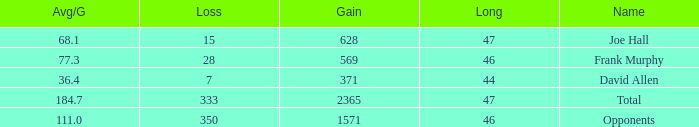How much Loss has a Gain smaller than 1571, and a Long smaller than 47, and an Avg/G of 36.4? 1.0. Can you give me this table as a dict? {'header': ['Avg/G', 'Loss', 'Gain', 'Long', 'Name'], 'rows': [['68.1', '15', '628', '47', 'Joe Hall'], ['77.3', '28', '569', '46', 'Frank Murphy'], ['36.4', '7', '371', '44', 'David Allen'], ['184.7', '333', '2365', '47', 'Total'], ['111.0', '350', '1571', '46', 'Opponents']]} 